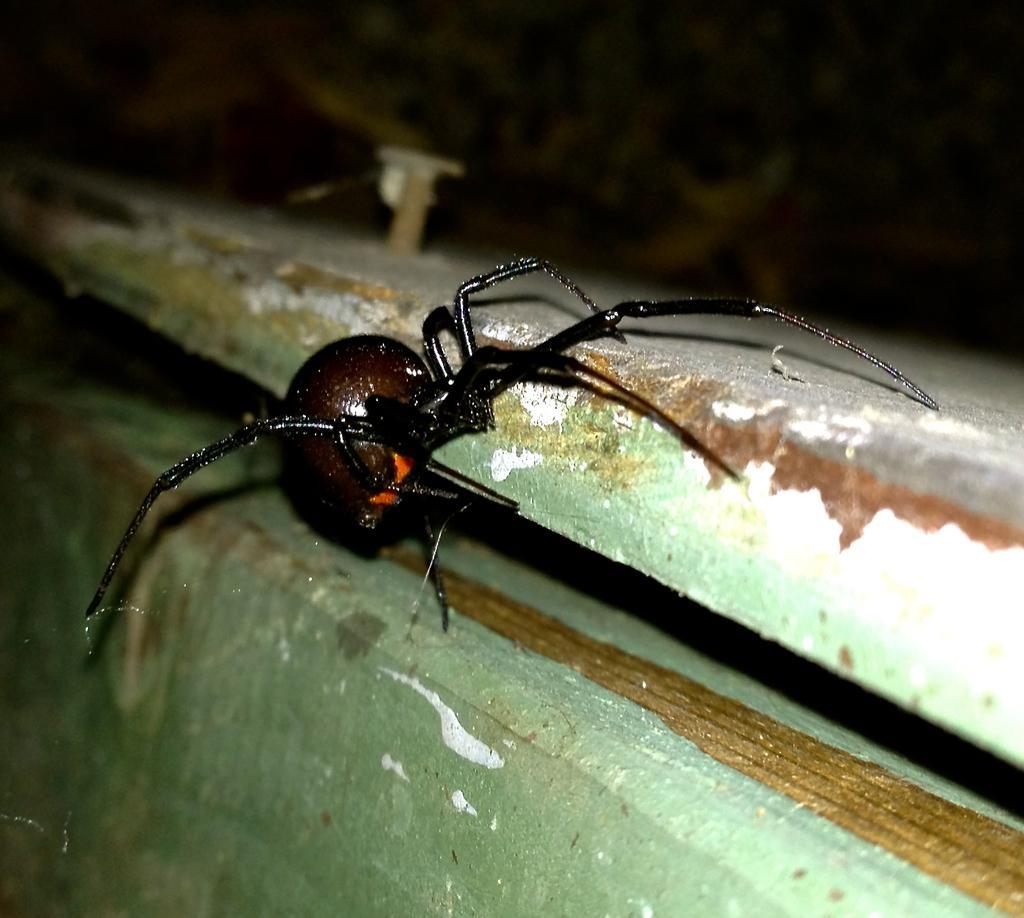Please provide a concise description of this image. In this image I can see an insect which is brown, black and orange in color on the wooden surface which is green, brown and white in color. I can see the blurry background. 